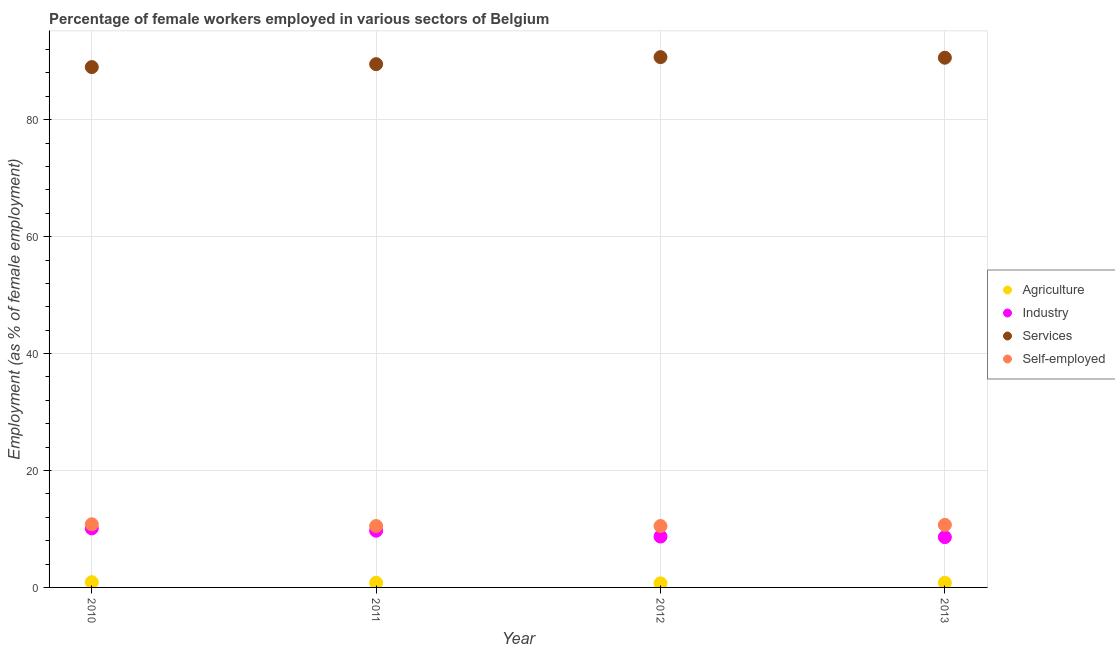Is the number of dotlines equal to the number of legend labels?
Your answer should be very brief. Yes. What is the percentage of female workers in industry in 2010?
Make the answer very short. 10.1. Across all years, what is the maximum percentage of self employed female workers?
Provide a short and direct response. 10.8. Across all years, what is the minimum percentage of female workers in agriculture?
Give a very brief answer. 0.7. What is the total percentage of female workers in industry in the graph?
Your answer should be very brief. 37.1. What is the difference between the percentage of female workers in industry in 2010 and that in 2012?
Keep it short and to the point. 1.4. What is the difference between the percentage of female workers in agriculture in 2012 and the percentage of female workers in services in 2013?
Offer a very short reply. -89.9. What is the average percentage of female workers in industry per year?
Make the answer very short. 9.28. In the year 2011, what is the difference between the percentage of female workers in services and percentage of female workers in industry?
Offer a terse response. 79.8. What is the ratio of the percentage of self employed female workers in 2012 to that in 2013?
Offer a very short reply. 0.98. What is the difference between the highest and the second highest percentage of self employed female workers?
Provide a succinct answer. 0.1. What is the difference between the highest and the lowest percentage of self employed female workers?
Your answer should be compact. 0.3. In how many years, is the percentage of female workers in industry greater than the average percentage of female workers in industry taken over all years?
Your answer should be very brief. 2. Is the sum of the percentage of female workers in services in 2012 and 2013 greater than the maximum percentage of self employed female workers across all years?
Ensure brevity in your answer.  Yes. Is it the case that in every year, the sum of the percentage of female workers in agriculture and percentage of female workers in industry is greater than the percentage of female workers in services?
Provide a short and direct response. No. Does the percentage of female workers in services monotonically increase over the years?
Your response must be concise. No. Is the percentage of self employed female workers strictly less than the percentage of female workers in agriculture over the years?
Offer a very short reply. No. How many years are there in the graph?
Offer a very short reply. 4. What is the difference between two consecutive major ticks on the Y-axis?
Your answer should be compact. 20. Does the graph contain grids?
Your response must be concise. Yes. Where does the legend appear in the graph?
Offer a very short reply. Center right. How many legend labels are there?
Provide a short and direct response. 4. What is the title of the graph?
Your answer should be compact. Percentage of female workers employed in various sectors of Belgium. Does "HFC gas" appear as one of the legend labels in the graph?
Offer a terse response. No. What is the label or title of the X-axis?
Ensure brevity in your answer.  Year. What is the label or title of the Y-axis?
Provide a short and direct response. Employment (as % of female employment). What is the Employment (as % of female employment) in Agriculture in 2010?
Your response must be concise. 0.9. What is the Employment (as % of female employment) in Industry in 2010?
Provide a succinct answer. 10.1. What is the Employment (as % of female employment) of Services in 2010?
Your answer should be compact. 89. What is the Employment (as % of female employment) of Self-employed in 2010?
Provide a succinct answer. 10.8. What is the Employment (as % of female employment) of Agriculture in 2011?
Provide a succinct answer. 0.8. What is the Employment (as % of female employment) of Industry in 2011?
Offer a terse response. 9.7. What is the Employment (as % of female employment) of Services in 2011?
Provide a short and direct response. 89.5. What is the Employment (as % of female employment) of Agriculture in 2012?
Your answer should be very brief. 0.7. What is the Employment (as % of female employment) in Industry in 2012?
Give a very brief answer. 8.7. What is the Employment (as % of female employment) of Services in 2012?
Your answer should be compact. 90.7. What is the Employment (as % of female employment) of Self-employed in 2012?
Your answer should be compact. 10.5. What is the Employment (as % of female employment) of Agriculture in 2013?
Your answer should be compact. 0.8. What is the Employment (as % of female employment) of Industry in 2013?
Your answer should be very brief. 8.6. What is the Employment (as % of female employment) in Services in 2013?
Offer a terse response. 90.6. What is the Employment (as % of female employment) in Self-employed in 2013?
Provide a succinct answer. 10.7. Across all years, what is the maximum Employment (as % of female employment) of Agriculture?
Offer a very short reply. 0.9. Across all years, what is the maximum Employment (as % of female employment) of Industry?
Offer a very short reply. 10.1. Across all years, what is the maximum Employment (as % of female employment) in Services?
Keep it short and to the point. 90.7. Across all years, what is the maximum Employment (as % of female employment) of Self-employed?
Your answer should be compact. 10.8. Across all years, what is the minimum Employment (as % of female employment) of Agriculture?
Provide a short and direct response. 0.7. Across all years, what is the minimum Employment (as % of female employment) in Industry?
Your answer should be very brief. 8.6. Across all years, what is the minimum Employment (as % of female employment) of Services?
Your response must be concise. 89. Across all years, what is the minimum Employment (as % of female employment) in Self-employed?
Offer a terse response. 10.5. What is the total Employment (as % of female employment) in Agriculture in the graph?
Provide a succinct answer. 3.2. What is the total Employment (as % of female employment) of Industry in the graph?
Make the answer very short. 37.1. What is the total Employment (as % of female employment) in Services in the graph?
Provide a short and direct response. 359.8. What is the total Employment (as % of female employment) in Self-employed in the graph?
Your answer should be very brief. 42.5. What is the difference between the Employment (as % of female employment) of Agriculture in 2010 and that in 2011?
Provide a succinct answer. 0.1. What is the difference between the Employment (as % of female employment) of Industry in 2010 and that in 2011?
Offer a terse response. 0.4. What is the difference between the Employment (as % of female employment) in Agriculture in 2010 and that in 2012?
Make the answer very short. 0.2. What is the difference between the Employment (as % of female employment) in Services in 2010 and that in 2012?
Your response must be concise. -1.7. What is the difference between the Employment (as % of female employment) of Agriculture in 2010 and that in 2013?
Give a very brief answer. 0.1. What is the difference between the Employment (as % of female employment) in Industry in 2010 and that in 2013?
Keep it short and to the point. 1.5. What is the difference between the Employment (as % of female employment) in Agriculture in 2011 and that in 2012?
Your answer should be very brief. 0.1. What is the difference between the Employment (as % of female employment) in Services in 2011 and that in 2012?
Your response must be concise. -1.2. What is the difference between the Employment (as % of female employment) in Agriculture in 2011 and that in 2013?
Make the answer very short. 0. What is the difference between the Employment (as % of female employment) of Industry in 2011 and that in 2013?
Offer a very short reply. 1.1. What is the difference between the Employment (as % of female employment) of Self-employed in 2011 and that in 2013?
Ensure brevity in your answer.  -0.2. What is the difference between the Employment (as % of female employment) of Agriculture in 2012 and that in 2013?
Your answer should be very brief. -0.1. What is the difference between the Employment (as % of female employment) in Agriculture in 2010 and the Employment (as % of female employment) in Services in 2011?
Make the answer very short. -88.6. What is the difference between the Employment (as % of female employment) of Agriculture in 2010 and the Employment (as % of female employment) of Self-employed in 2011?
Provide a succinct answer. -9.6. What is the difference between the Employment (as % of female employment) of Industry in 2010 and the Employment (as % of female employment) of Services in 2011?
Offer a terse response. -79.4. What is the difference between the Employment (as % of female employment) of Services in 2010 and the Employment (as % of female employment) of Self-employed in 2011?
Ensure brevity in your answer.  78.5. What is the difference between the Employment (as % of female employment) of Agriculture in 2010 and the Employment (as % of female employment) of Services in 2012?
Provide a succinct answer. -89.8. What is the difference between the Employment (as % of female employment) of Agriculture in 2010 and the Employment (as % of female employment) of Self-employed in 2012?
Offer a terse response. -9.6. What is the difference between the Employment (as % of female employment) of Industry in 2010 and the Employment (as % of female employment) of Services in 2012?
Make the answer very short. -80.6. What is the difference between the Employment (as % of female employment) in Industry in 2010 and the Employment (as % of female employment) in Self-employed in 2012?
Your answer should be compact. -0.4. What is the difference between the Employment (as % of female employment) in Services in 2010 and the Employment (as % of female employment) in Self-employed in 2012?
Your answer should be compact. 78.5. What is the difference between the Employment (as % of female employment) in Agriculture in 2010 and the Employment (as % of female employment) in Services in 2013?
Provide a short and direct response. -89.7. What is the difference between the Employment (as % of female employment) of Agriculture in 2010 and the Employment (as % of female employment) of Self-employed in 2013?
Provide a succinct answer. -9.8. What is the difference between the Employment (as % of female employment) of Industry in 2010 and the Employment (as % of female employment) of Services in 2013?
Your answer should be compact. -80.5. What is the difference between the Employment (as % of female employment) of Services in 2010 and the Employment (as % of female employment) of Self-employed in 2013?
Provide a short and direct response. 78.3. What is the difference between the Employment (as % of female employment) of Agriculture in 2011 and the Employment (as % of female employment) of Industry in 2012?
Provide a short and direct response. -7.9. What is the difference between the Employment (as % of female employment) in Agriculture in 2011 and the Employment (as % of female employment) in Services in 2012?
Provide a short and direct response. -89.9. What is the difference between the Employment (as % of female employment) of Industry in 2011 and the Employment (as % of female employment) of Services in 2012?
Offer a terse response. -81. What is the difference between the Employment (as % of female employment) in Services in 2011 and the Employment (as % of female employment) in Self-employed in 2012?
Your answer should be very brief. 79. What is the difference between the Employment (as % of female employment) in Agriculture in 2011 and the Employment (as % of female employment) in Industry in 2013?
Provide a succinct answer. -7.8. What is the difference between the Employment (as % of female employment) in Agriculture in 2011 and the Employment (as % of female employment) in Services in 2013?
Give a very brief answer. -89.8. What is the difference between the Employment (as % of female employment) in Industry in 2011 and the Employment (as % of female employment) in Services in 2013?
Make the answer very short. -80.9. What is the difference between the Employment (as % of female employment) in Industry in 2011 and the Employment (as % of female employment) in Self-employed in 2013?
Your response must be concise. -1. What is the difference between the Employment (as % of female employment) in Services in 2011 and the Employment (as % of female employment) in Self-employed in 2013?
Offer a terse response. 78.8. What is the difference between the Employment (as % of female employment) in Agriculture in 2012 and the Employment (as % of female employment) in Industry in 2013?
Your answer should be compact. -7.9. What is the difference between the Employment (as % of female employment) of Agriculture in 2012 and the Employment (as % of female employment) of Services in 2013?
Ensure brevity in your answer.  -89.9. What is the difference between the Employment (as % of female employment) in Agriculture in 2012 and the Employment (as % of female employment) in Self-employed in 2013?
Offer a terse response. -10. What is the difference between the Employment (as % of female employment) in Industry in 2012 and the Employment (as % of female employment) in Services in 2013?
Your response must be concise. -81.9. What is the average Employment (as % of female employment) of Agriculture per year?
Offer a very short reply. 0.8. What is the average Employment (as % of female employment) in Industry per year?
Provide a short and direct response. 9.28. What is the average Employment (as % of female employment) of Services per year?
Offer a terse response. 89.95. What is the average Employment (as % of female employment) of Self-employed per year?
Ensure brevity in your answer.  10.62. In the year 2010, what is the difference between the Employment (as % of female employment) of Agriculture and Employment (as % of female employment) of Industry?
Offer a terse response. -9.2. In the year 2010, what is the difference between the Employment (as % of female employment) of Agriculture and Employment (as % of female employment) of Services?
Your answer should be compact. -88.1. In the year 2010, what is the difference between the Employment (as % of female employment) of Industry and Employment (as % of female employment) of Services?
Provide a succinct answer. -78.9. In the year 2010, what is the difference between the Employment (as % of female employment) in Industry and Employment (as % of female employment) in Self-employed?
Your answer should be very brief. -0.7. In the year 2010, what is the difference between the Employment (as % of female employment) of Services and Employment (as % of female employment) of Self-employed?
Offer a terse response. 78.2. In the year 2011, what is the difference between the Employment (as % of female employment) in Agriculture and Employment (as % of female employment) in Services?
Your answer should be very brief. -88.7. In the year 2011, what is the difference between the Employment (as % of female employment) of Industry and Employment (as % of female employment) of Services?
Make the answer very short. -79.8. In the year 2011, what is the difference between the Employment (as % of female employment) of Services and Employment (as % of female employment) of Self-employed?
Make the answer very short. 79. In the year 2012, what is the difference between the Employment (as % of female employment) in Agriculture and Employment (as % of female employment) in Industry?
Provide a succinct answer. -8. In the year 2012, what is the difference between the Employment (as % of female employment) in Agriculture and Employment (as % of female employment) in Services?
Your answer should be very brief. -90. In the year 2012, what is the difference between the Employment (as % of female employment) in Industry and Employment (as % of female employment) in Services?
Offer a terse response. -82. In the year 2012, what is the difference between the Employment (as % of female employment) of Services and Employment (as % of female employment) of Self-employed?
Offer a terse response. 80.2. In the year 2013, what is the difference between the Employment (as % of female employment) of Agriculture and Employment (as % of female employment) of Industry?
Offer a terse response. -7.8. In the year 2013, what is the difference between the Employment (as % of female employment) in Agriculture and Employment (as % of female employment) in Services?
Your answer should be very brief. -89.8. In the year 2013, what is the difference between the Employment (as % of female employment) in Industry and Employment (as % of female employment) in Services?
Your answer should be very brief. -82. In the year 2013, what is the difference between the Employment (as % of female employment) in Services and Employment (as % of female employment) in Self-employed?
Give a very brief answer. 79.9. What is the ratio of the Employment (as % of female employment) of Agriculture in 2010 to that in 2011?
Provide a short and direct response. 1.12. What is the ratio of the Employment (as % of female employment) of Industry in 2010 to that in 2011?
Make the answer very short. 1.04. What is the ratio of the Employment (as % of female employment) of Self-employed in 2010 to that in 2011?
Provide a succinct answer. 1.03. What is the ratio of the Employment (as % of female employment) in Agriculture in 2010 to that in 2012?
Provide a succinct answer. 1.29. What is the ratio of the Employment (as % of female employment) in Industry in 2010 to that in 2012?
Offer a very short reply. 1.16. What is the ratio of the Employment (as % of female employment) of Services in 2010 to that in 2012?
Your answer should be compact. 0.98. What is the ratio of the Employment (as % of female employment) in Self-employed in 2010 to that in 2012?
Keep it short and to the point. 1.03. What is the ratio of the Employment (as % of female employment) in Agriculture in 2010 to that in 2013?
Your response must be concise. 1.12. What is the ratio of the Employment (as % of female employment) in Industry in 2010 to that in 2013?
Provide a succinct answer. 1.17. What is the ratio of the Employment (as % of female employment) of Services in 2010 to that in 2013?
Your response must be concise. 0.98. What is the ratio of the Employment (as % of female employment) of Self-employed in 2010 to that in 2013?
Give a very brief answer. 1.01. What is the ratio of the Employment (as % of female employment) in Industry in 2011 to that in 2012?
Keep it short and to the point. 1.11. What is the ratio of the Employment (as % of female employment) of Services in 2011 to that in 2012?
Keep it short and to the point. 0.99. What is the ratio of the Employment (as % of female employment) in Self-employed in 2011 to that in 2012?
Keep it short and to the point. 1. What is the ratio of the Employment (as % of female employment) of Agriculture in 2011 to that in 2013?
Keep it short and to the point. 1. What is the ratio of the Employment (as % of female employment) of Industry in 2011 to that in 2013?
Keep it short and to the point. 1.13. What is the ratio of the Employment (as % of female employment) in Services in 2011 to that in 2013?
Give a very brief answer. 0.99. What is the ratio of the Employment (as % of female employment) in Self-employed in 2011 to that in 2013?
Your response must be concise. 0.98. What is the ratio of the Employment (as % of female employment) in Agriculture in 2012 to that in 2013?
Make the answer very short. 0.88. What is the ratio of the Employment (as % of female employment) of Industry in 2012 to that in 2013?
Keep it short and to the point. 1.01. What is the ratio of the Employment (as % of female employment) in Self-employed in 2012 to that in 2013?
Keep it short and to the point. 0.98. What is the difference between the highest and the second highest Employment (as % of female employment) of Agriculture?
Your answer should be very brief. 0.1. What is the difference between the highest and the second highest Employment (as % of female employment) in Industry?
Your response must be concise. 0.4. What is the difference between the highest and the second highest Employment (as % of female employment) in Self-employed?
Give a very brief answer. 0.1. What is the difference between the highest and the lowest Employment (as % of female employment) in Industry?
Provide a short and direct response. 1.5. 